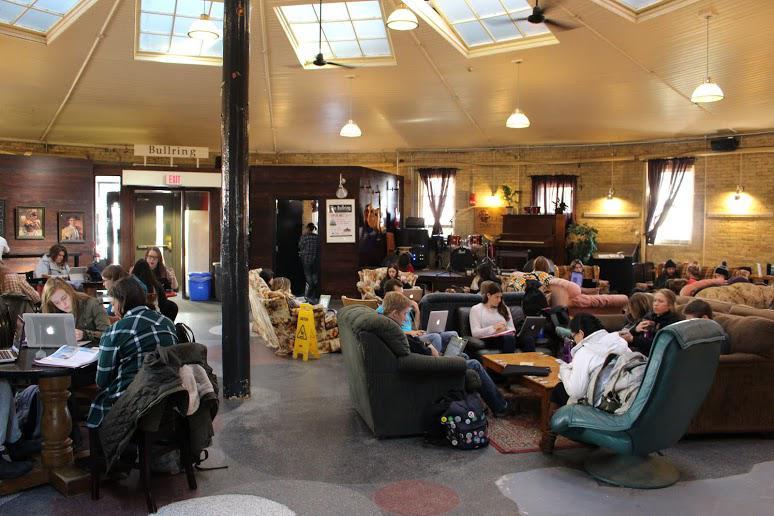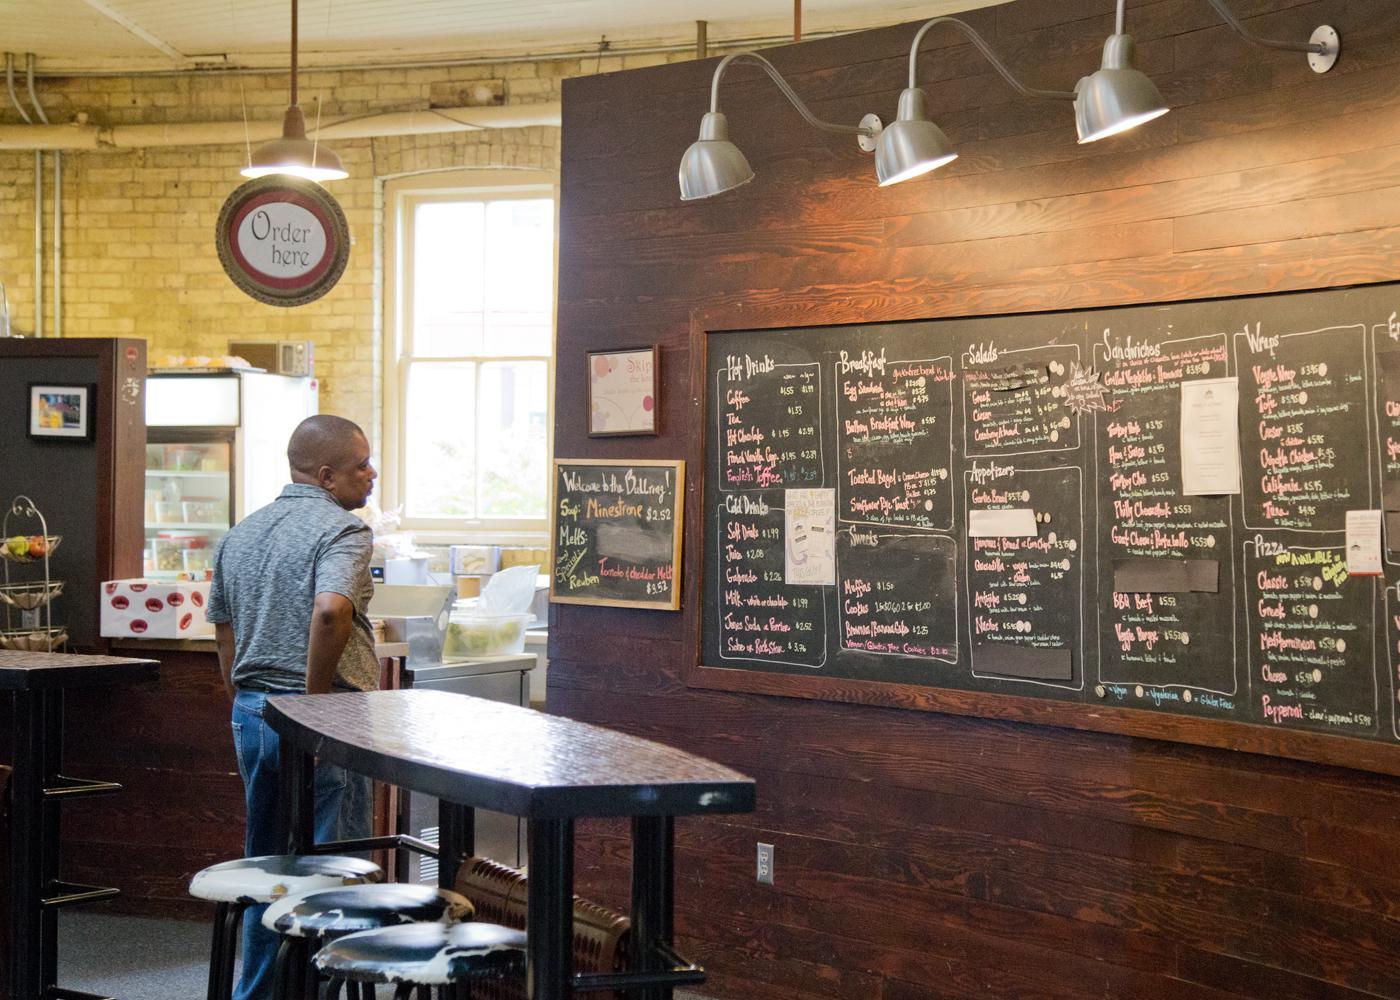The first image is the image on the left, the second image is the image on the right. Considering the images on both sides, is "There are both bar stools and chairs." valid? Answer yes or no. Yes. The first image is the image on the left, the second image is the image on the right. Analyze the images presented: Is the assertion "One image shows an interior with a black column in the center, dome-shaped suspended lights, and paned square windows in the ceiling." valid? Answer yes or no. Yes. 